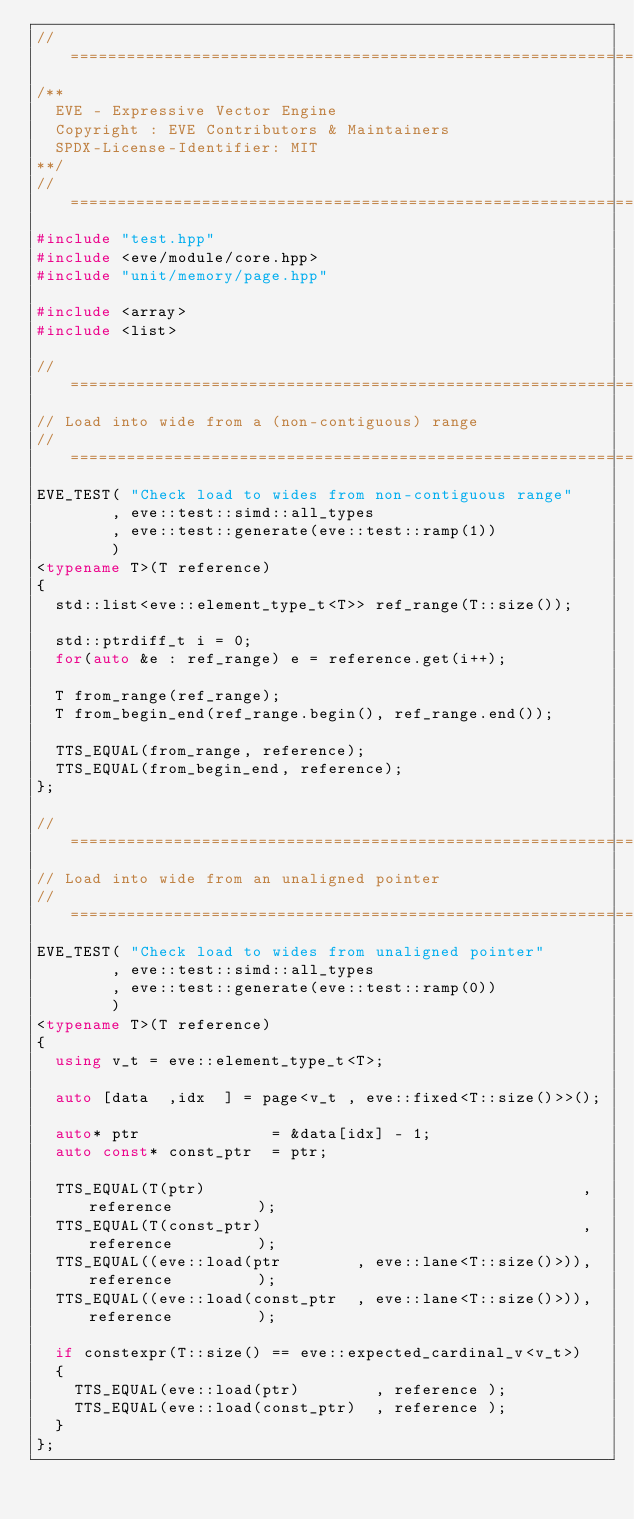Convert code to text. <code><loc_0><loc_0><loc_500><loc_500><_C++_>//==================================================================================================
/**
  EVE - Expressive Vector Engine
  Copyright : EVE Contributors & Maintainers
  SPDX-License-Identifier: MIT
**/
//==================================================================================================
#include "test.hpp"
#include <eve/module/core.hpp>
#include "unit/memory/page.hpp"

#include <array>
#include <list>

//==================================================================================================
// Load into wide from a (non-contiguous) range
//==================================================================================================
EVE_TEST( "Check load to wides from non-contiguous range"
        , eve::test::simd::all_types
        , eve::test::generate(eve::test::ramp(1))
        )
<typename T>(T reference)
{
  std::list<eve::element_type_t<T>> ref_range(T::size());

  std::ptrdiff_t i = 0;
  for(auto &e : ref_range) e = reference.get(i++);

  T from_range(ref_range);
  T from_begin_end(ref_range.begin(), ref_range.end());

  TTS_EQUAL(from_range, reference);
  TTS_EQUAL(from_begin_end, reference);
};

//==================================================================================================
// Load into wide from an unaligned pointer
//==================================================================================================
EVE_TEST( "Check load to wides from unaligned pointer"
        , eve::test::simd::all_types
        , eve::test::generate(eve::test::ramp(0))
        )
<typename T>(T reference)
{
  using v_t = eve::element_type_t<T>;

  auto [data  ,idx  ] = page<v_t , eve::fixed<T::size()>>();

  auto* ptr              = &data[idx] - 1;
  auto const* const_ptr  = ptr;

  TTS_EQUAL(T(ptr)                                        , reference         );
  TTS_EQUAL(T(const_ptr)                                  , reference         );
  TTS_EQUAL((eve::load(ptr        , eve::lane<T::size()>)), reference         );
  TTS_EQUAL((eve::load(const_ptr  , eve::lane<T::size()>)), reference         );

  if constexpr(T::size() == eve::expected_cardinal_v<v_t>)
  {
    TTS_EQUAL(eve::load(ptr)        , reference );
    TTS_EQUAL(eve::load(const_ptr)  , reference );
  }
};
</code> 